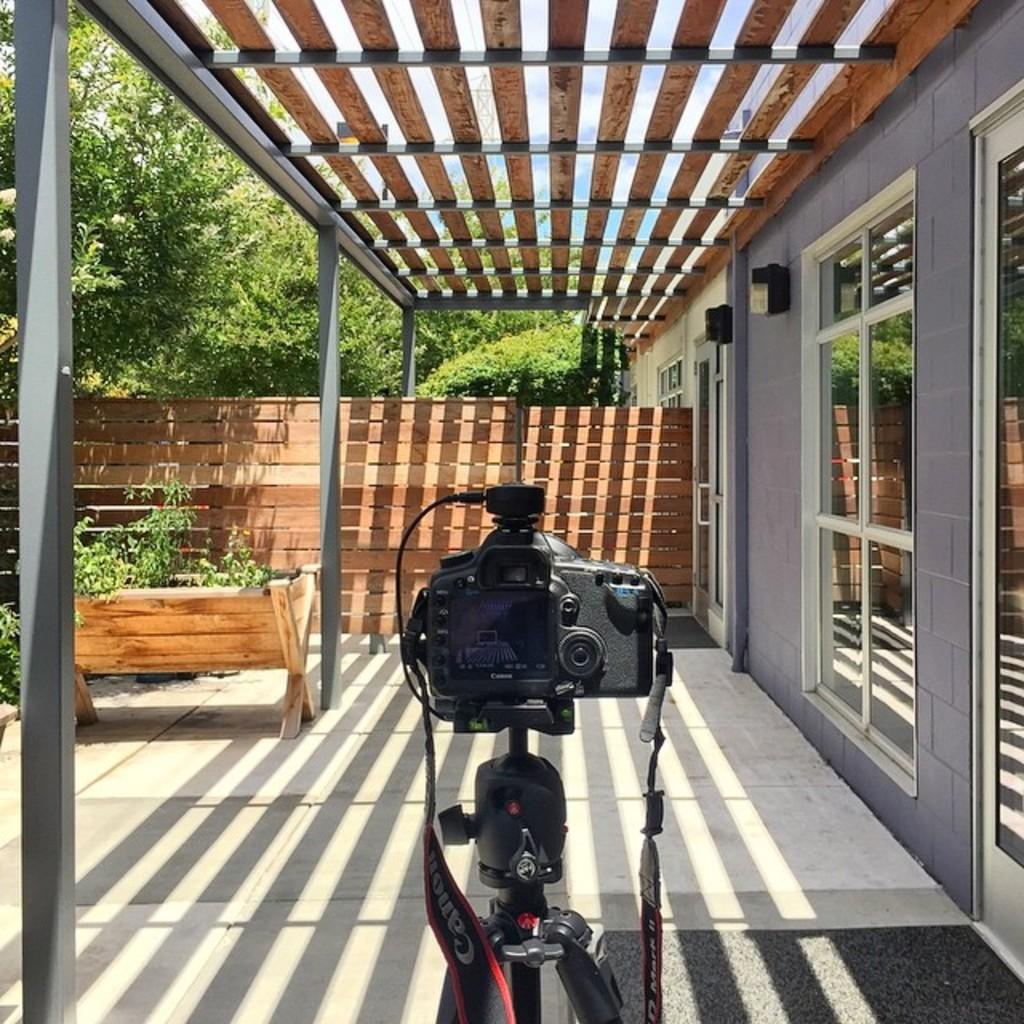What is placed on a stand in the image? There is a camera placed on a stand in the image. What type of material can be seen in the background of the image? There is a wooden wall in the image. What is located in front of the camera? Trees are present in front of the camera. What type of volcano can be seen erupting in the image? There is no volcano present in the image; it features a camera placed on a stand, a wooden wall, and trees. How many balloons are floating in the image? There are no balloons present in the image. 